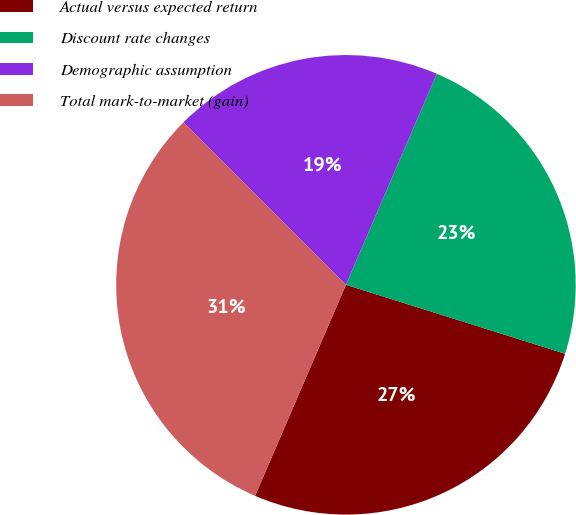<chart> <loc_0><loc_0><loc_500><loc_500><pie_chart><fcel>Actual versus expected return<fcel>Discount rate changes<fcel>Demographic assumption<fcel>Total mark-to-market (gain)<nl><fcel>26.62%<fcel>23.38%<fcel>18.97%<fcel>31.03%<nl></chart> 